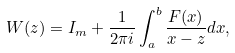Convert formula to latex. <formula><loc_0><loc_0><loc_500><loc_500>W ( z ) = I _ { m } + \frac { 1 } { 2 { \pi } i } \int _ { a } ^ { b } \frac { F ( x ) } { x - z } d x ,</formula> 